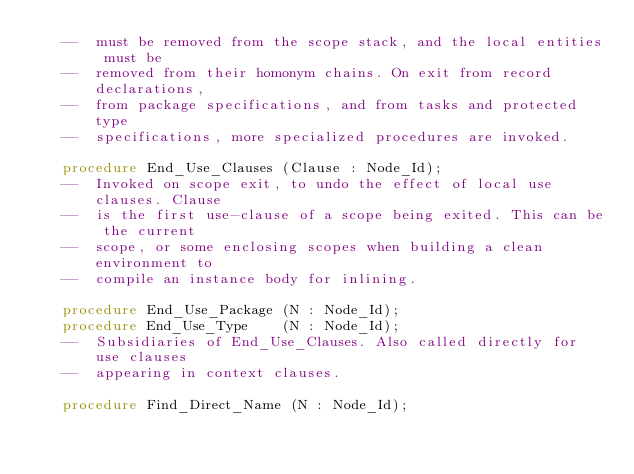<code> <loc_0><loc_0><loc_500><loc_500><_Ada_>   --  must be removed from the scope stack, and the local entities must be
   --  removed from their homonym chains. On exit from record declarations,
   --  from package specifications, and from tasks and protected type
   --  specifications, more specialized procedures are invoked.

   procedure End_Use_Clauses (Clause : Node_Id);
   --  Invoked on scope exit, to undo the effect of local use clauses. Clause
   --  is the first use-clause of a scope being exited. This can be the current
   --  scope, or some enclosing scopes when building a clean environment to
   --  compile an instance body for inlining.

   procedure End_Use_Package (N : Node_Id);
   procedure End_Use_Type    (N : Node_Id);
   --  Subsidiaries of End_Use_Clauses. Also called directly for use clauses
   --  appearing in context clauses.

   procedure Find_Direct_Name (N : Node_Id);</code> 